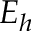Convert formula to latex. <formula><loc_0><loc_0><loc_500><loc_500>E _ { h }</formula> 